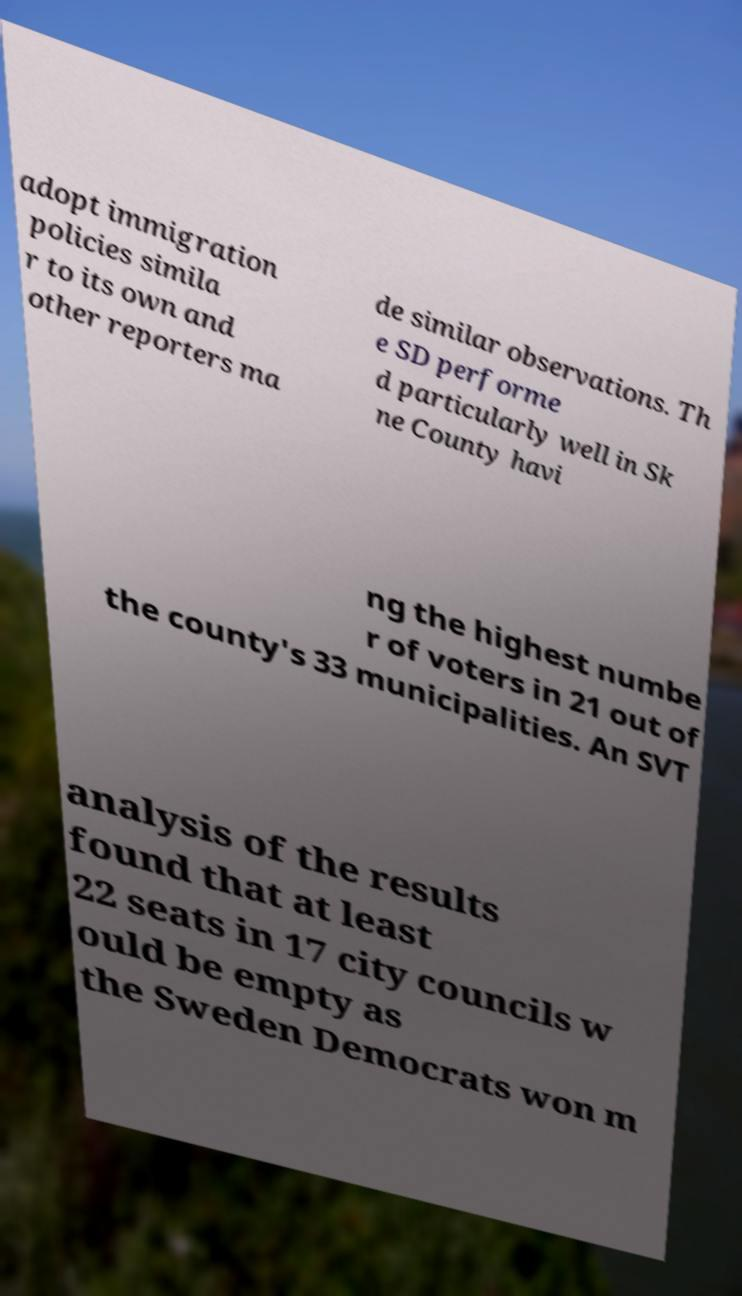Can you accurately transcribe the text from the provided image for me? adopt immigration policies simila r to its own and other reporters ma de similar observations. Th e SD performe d particularly well in Sk ne County havi ng the highest numbe r of voters in 21 out of the county's 33 municipalities. An SVT analysis of the results found that at least 22 seats in 17 city councils w ould be empty as the Sweden Democrats won m 